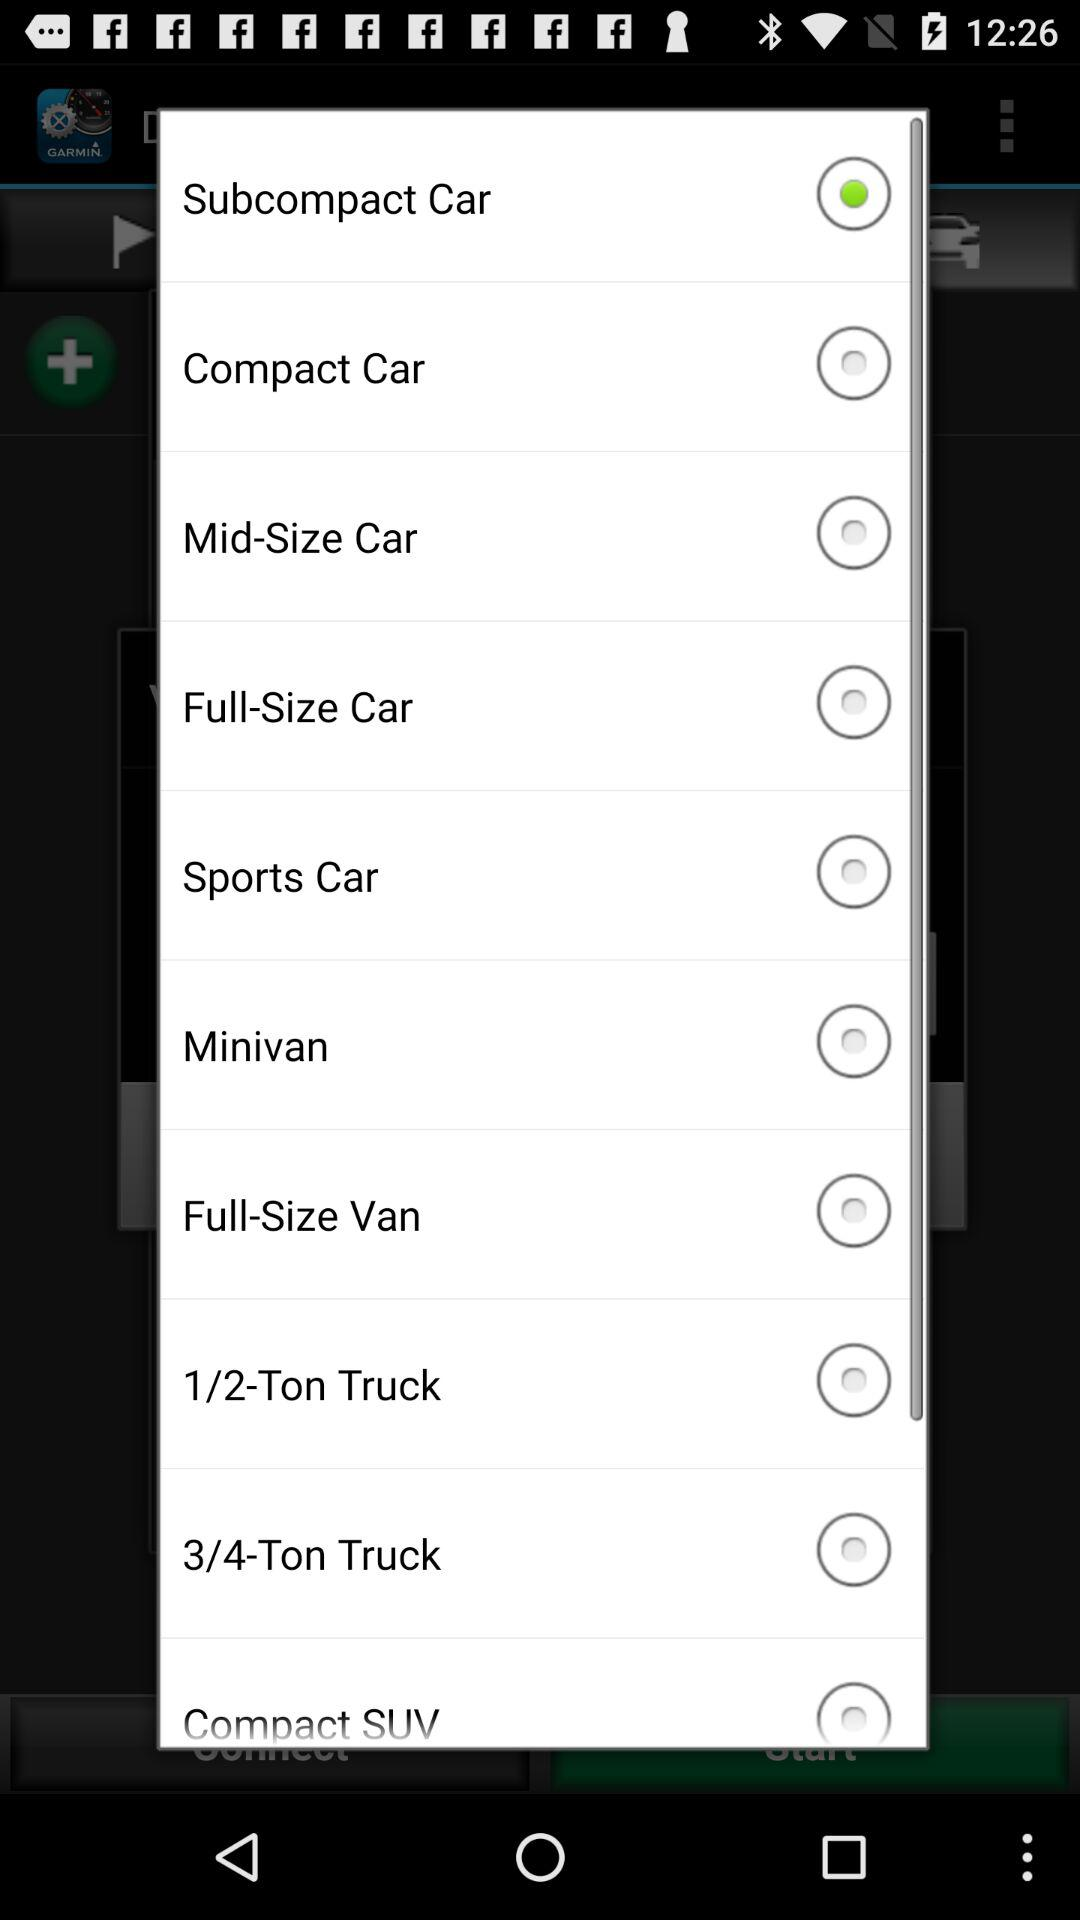Which option has been selected? The option "Subcompact Car" has been selected. 